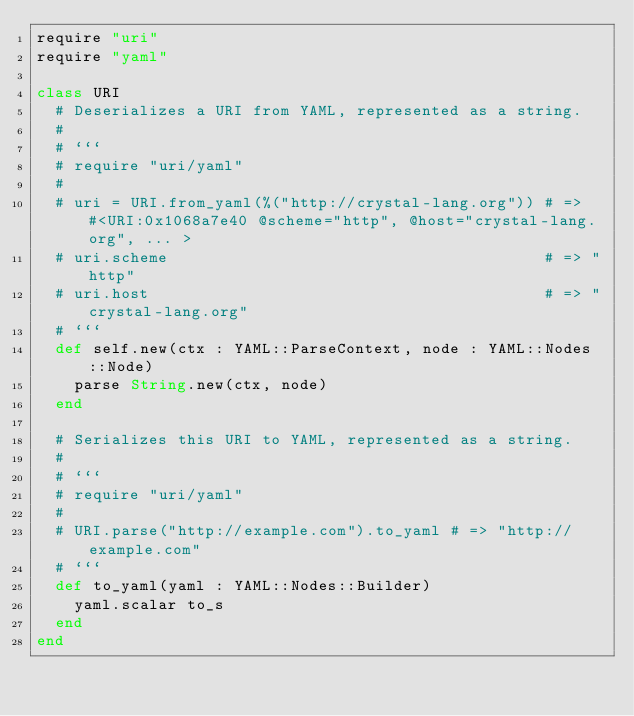<code> <loc_0><loc_0><loc_500><loc_500><_Crystal_>require "uri"
require "yaml"

class URI
  # Deserializes a URI from YAML, represented as a string.
  #
  # ```
  # require "uri/yaml"
  #
  # uri = URI.from_yaml(%("http://crystal-lang.org")) # => #<URI:0x1068a7e40 @scheme="http", @host="crystal-lang.org", ... >
  # uri.scheme                                        # => "http"
  # uri.host                                          # => "crystal-lang.org"
  # ```
  def self.new(ctx : YAML::ParseContext, node : YAML::Nodes::Node)
    parse String.new(ctx, node)
  end

  # Serializes this URI to YAML, represented as a string.
  #
  # ```
  # require "uri/yaml"
  #
  # URI.parse("http://example.com").to_yaml # => "http://example.com"
  # ```
  def to_yaml(yaml : YAML::Nodes::Builder)
    yaml.scalar to_s
  end
end
</code> 